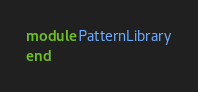Convert code to text. <code><loc_0><loc_0><loc_500><loc_500><_Ruby_>
module PatternLibrary
end
</code> 